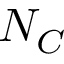Convert formula to latex. <formula><loc_0><loc_0><loc_500><loc_500>N _ { C }</formula> 